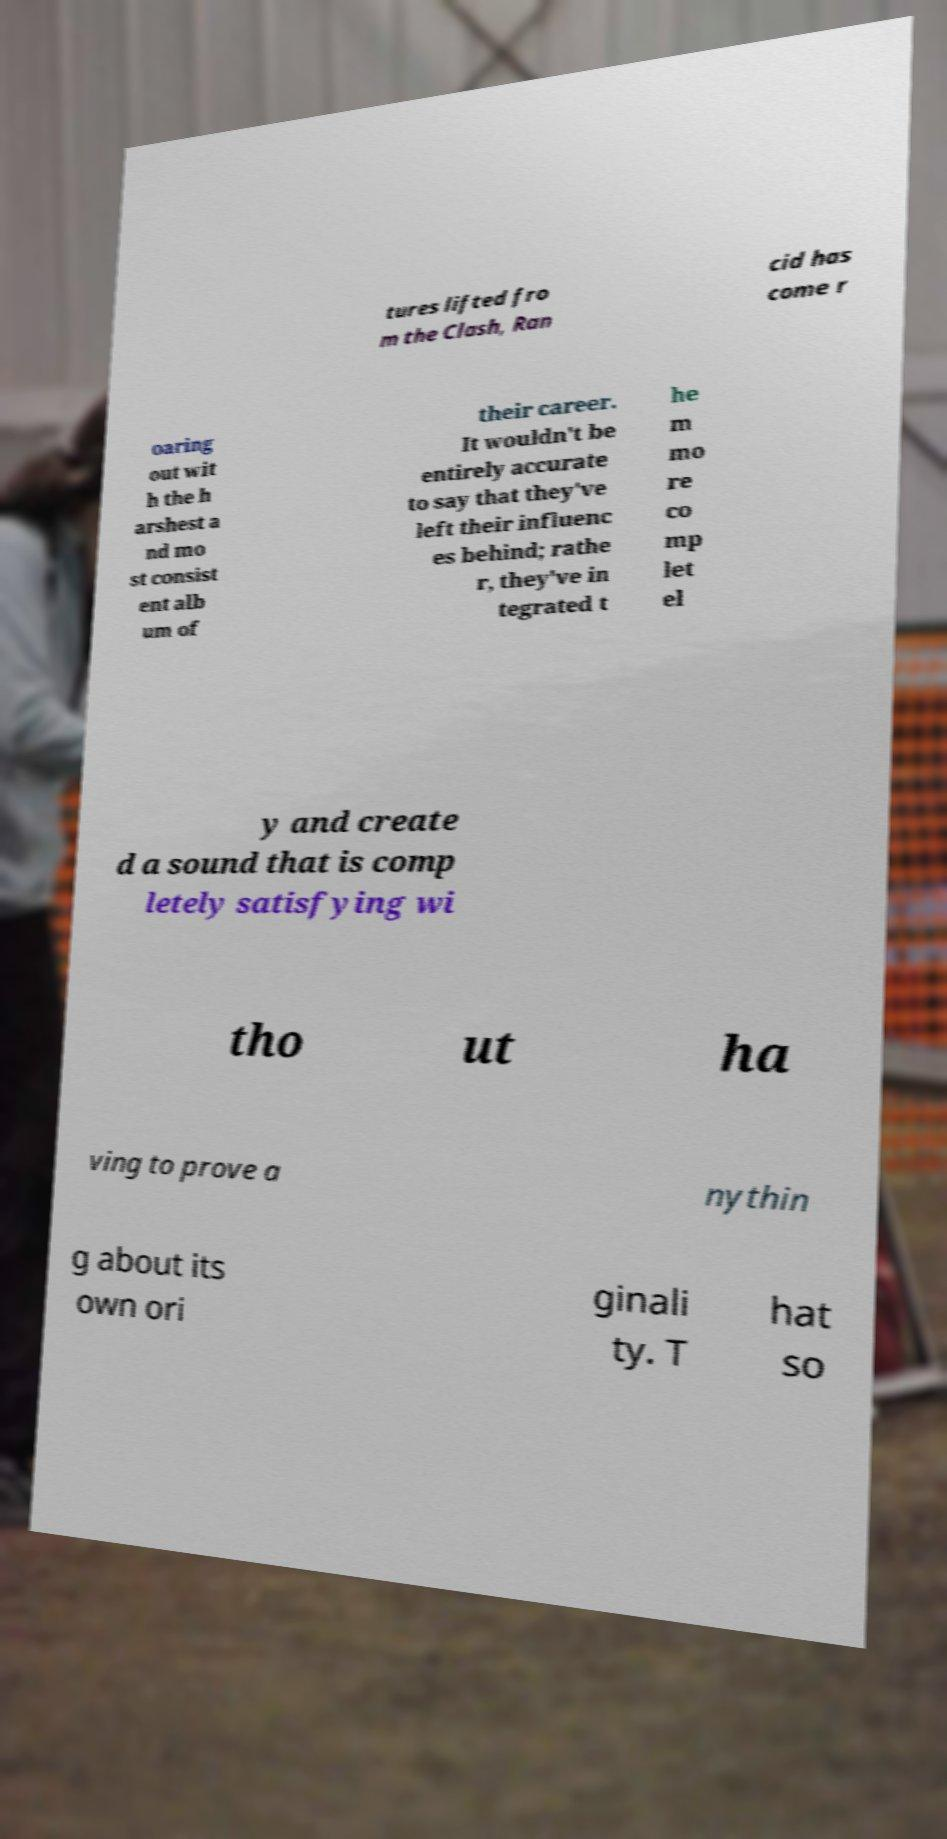I need the written content from this picture converted into text. Can you do that? tures lifted fro m the Clash, Ran cid has come r oaring out wit h the h arshest a nd mo st consist ent alb um of their career. It wouldn't be entirely accurate to say that they've left their influenc es behind; rathe r, they've in tegrated t he m mo re co mp let el y and create d a sound that is comp letely satisfying wi tho ut ha ving to prove a nythin g about its own ori ginali ty. T hat so 